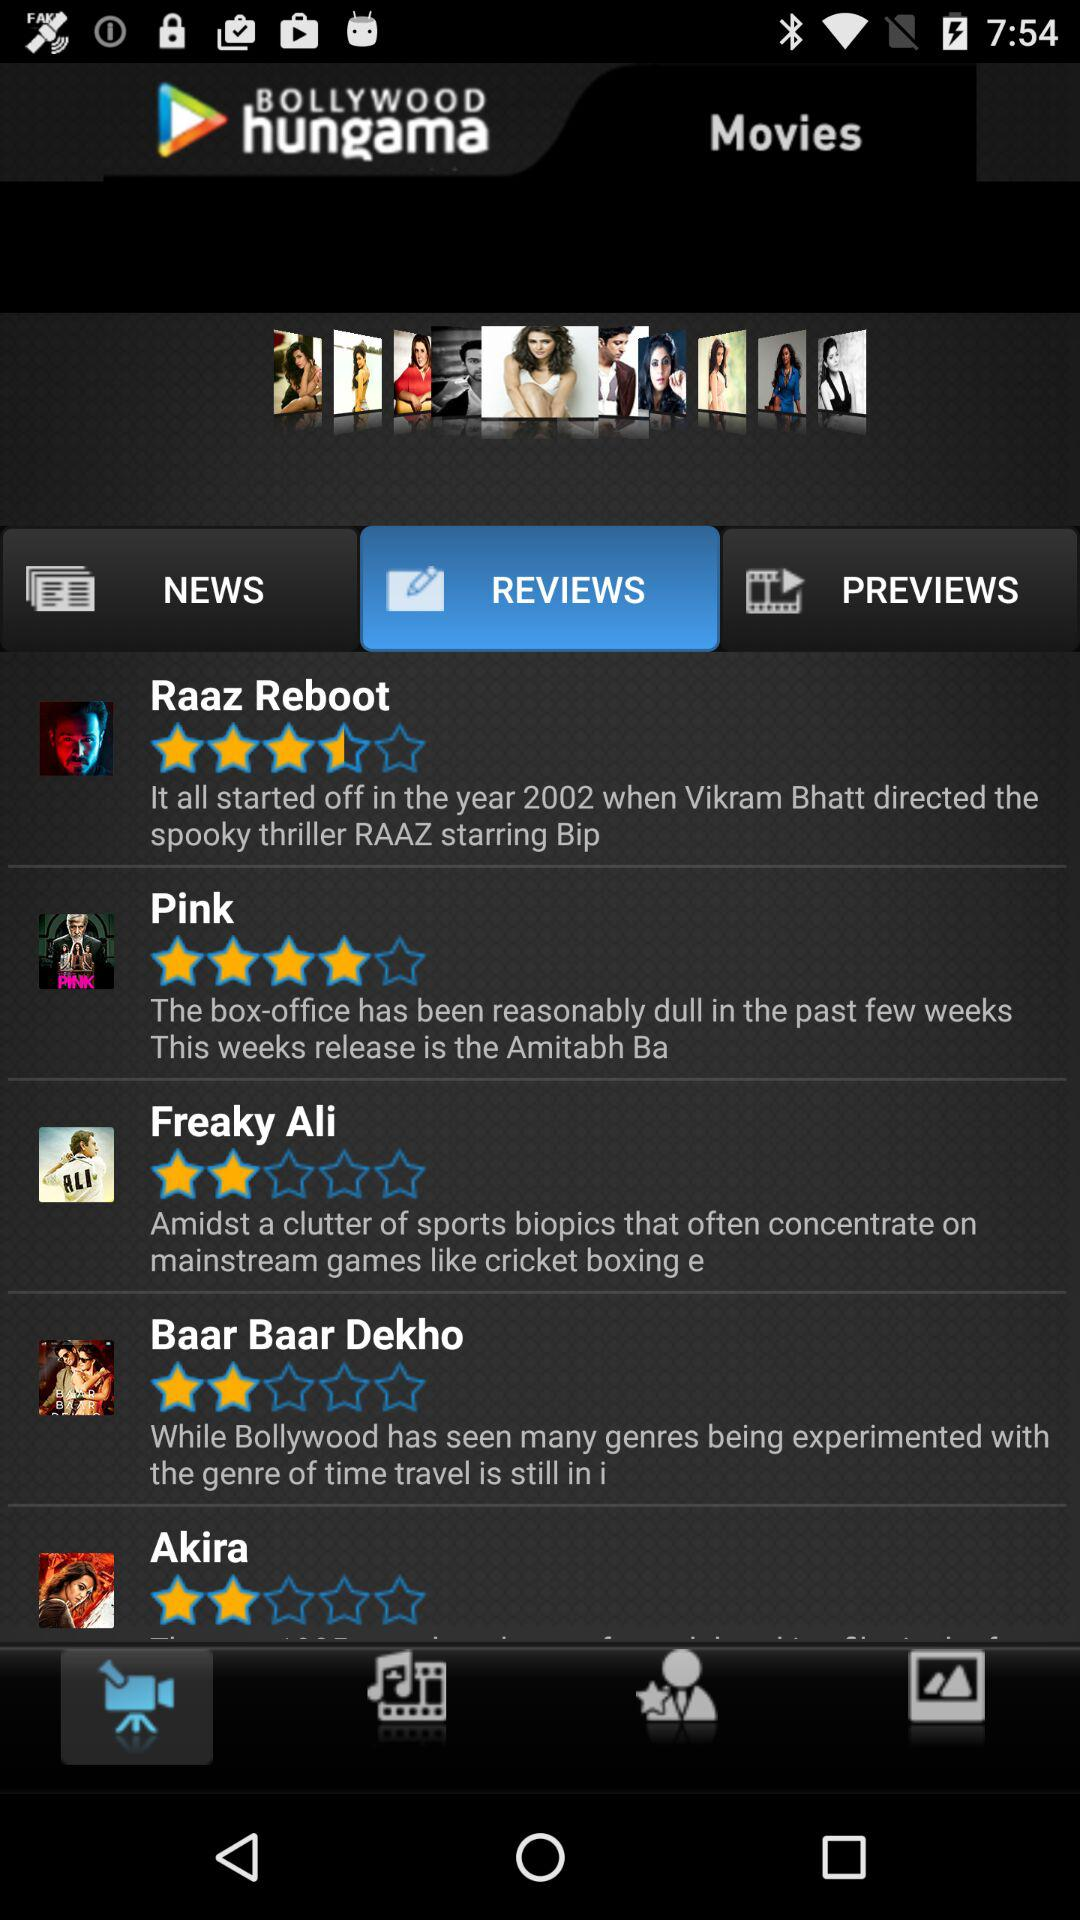What is the application name? The application name is "BOLLYWOOD hungama". 